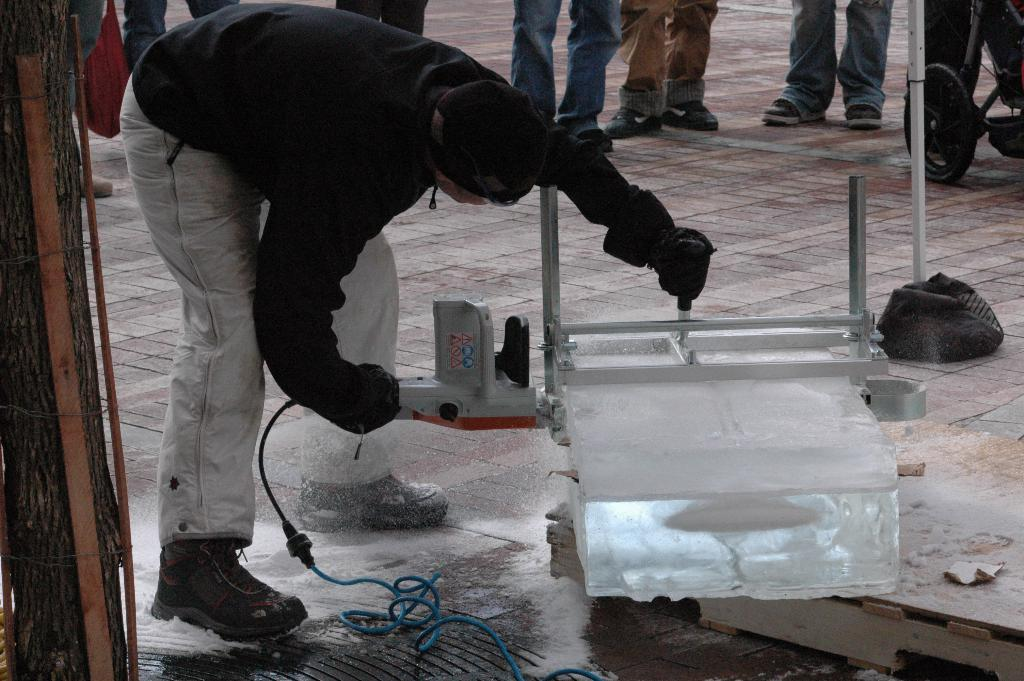What is the person on the left side of the image doing? The person is bending and working on the left side of the image. What is located beside the person? There is an object beside the person. Can you describe the background of the image? There are other people and a vehicle in the background of the image, as well as a pole. What type of oven can be seen in the image? There is no oven present in the image. How many bombs are visible in the image? There are no bombs present in the image. 